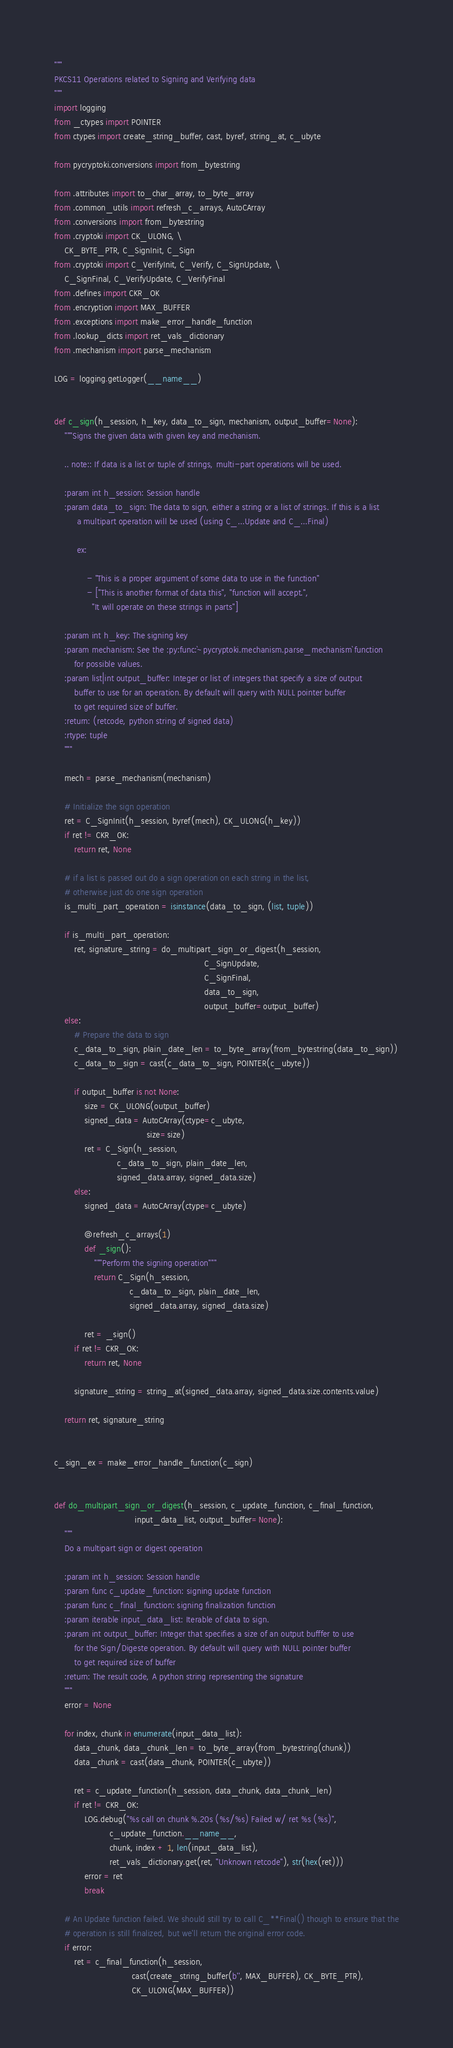Convert code to text. <code><loc_0><loc_0><loc_500><loc_500><_Python_>"""
PKCS11 Operations related to Signing and Verifying data
"""
import logging
from _ctypes import POINTER
from ctypes import create_string_buffer, cast, byref, string_at, c_ubyte

from pycryptoki.conversions import from_bytestring

from .attributes import to_char_array, to_byte_array
from .common_utils import refresh_c_arrays, AutoCArray
from .conversions import from_bytestring
from .cryptoki import CK_ULONG, \
    CK_BYTE_PTR, C_SignInit, C_Sign
from .cryptoki import C_VerifyInit, C_Verify, C_SignUpdate, \
    C_SignFinal, C_VerifyUpdate, C_VerifyFinal
from .defines import CKR_OK
from .encryption import MAX_BUFFER
from .exceptions import make_error_handle_function
from .lookup_dicts import ret_vals_dictionary
from .mechanism import parse_mechanism

LOG = logging.getLogger(__name__)


def c_sign(h_session, h_key, data_to_sign, mechanism, output_buffer=None):
    """Signs the given data with given key and mechanism.

    .. note:: If data is a list or tuple of strings, multi-part operations will be used.

    :param int h_session: Session handle
    :param data_to_sign: The data to sign, either a string or a list of strings. If this is a list
         a multipart operation will be used (using C_...Update and C_...Final)

         ex:

             - "This is a proper argument of some data to use in the function"
             - ["This is another format of data this", "function will accept.",
               "It will operate on these strings in parts"]

    :param int h_key: The signing key
    :param mechanism: See the :py:func:`~pycryptoki.mechanism.parse_mechanism` function
        for possible values.
    :param list|int output_buffer: Integer or list of integers that specify a size of output
        buffer to use for an operation. By default will query with NULL pointer buffer
        to get required size of buffer.
    :return: (retcode, python string of signed data)
    :rtype: tuple
    """

    mech = parse_mechanism(mechanism)

    # Initialize the sign operation
    ret = C_SignInit(h_session, byref(mech), CK_ULONG(h_key))
    if ret != CKR_OK:
        return ret, None

    # if a list is passed out do a sign operation on each string in the list,
    # otherwise just do one sign operation
    is_multi_part_operation = isinstance(data_to_sign, (list, tuple))

    if is_multi_part_operation:
        ret, signature_string = do_multipart_sign_or_digest(h_session,
                                                            C_SignUpdate,
                                                            C_SignFinal,
                                                            data_to_sign,
                                                            output_buffer=output_buffer)
    else:
        # Prepare the data to sign
        c_data_to_sign, plain_date_len = to_byte_array(from_bytestring(data_to_sign))
        c_data_to_sign = cast(c_data_to_sign, POINTER(c_ubyte))

        if output_buffer is not None:
            size = CK_ULONG(output_buffer)
            signed_data = AutoCArray(ctype=c_ubyte,
                                     size=size)
            ret = C_Sign(h_session,
                         c_data_to_sign, plain_date_len,
                         signed_data.array, signed_data.size)
        else:
            signed_data = AutoCArray(ctype=c_ubyte)

            @refresh_c_arrays(1)
            def _sign():
                """Perform the signing operation"""
                return C_Sign(h_session,
                              c_data_to_sign, plain_date_len,
                              signed_data.array, signed_data.size)

            ret = _sign()
        if ret != CKR_OK:
            return ret, None

        signature_string = string_at(signed_data.array, signed_data.size.contents.value)

    return ret, signature_string


c_sign_ex = make_error_handle_function(c_sign)


def do_multipart_sign_or_digest(h_session, c_update_function, c_final_function,
                                input_data_list, output_buffer=None):
    """
    Do a multipart sign or digest operation

    :param int h_session: Session handle
    :param func c_update_function: signing update function
    :param func c_final_function: signing finalization function
    :param iterable input_data_list: Iterable of data to sign.
    :param int output_buffer: Integer that specifies a size of an output bufffer to use
        for the Sign/Digeste operation. By default will query with NULL pointer buffer
        to get required size of buffer
    :return: The result code, A python string representing the signature
    """
    error = None

    for index, chunk in enumerate(input_data_list):
        data_chunk, data_chunk_len = to_byte_array(from_bytestring(chunk))
        data_chunk = cast(data_chunk, POINTER(c_ubyte))

        ret = c_update_function(h_session, data_chunk, data_chunk_len)
        if ret != CKR_OK:
            LOG.debug("%s call on chunk %.20s (%s/%s) Failed w/ ret %s (%s)",
                      c_update_function.__name__,
                      chunk, index + 1, len(input_data_list),
                      ret_vals_dictionary.get(ret, "Unknown retcode"), str(hex(ret)))
            error = ret
            break

    # An Update function failed. We should still try to call C_**Final() though to ensure that the
    # operation is still finalized, but we'll return the original error code. 
    if error:
        ret = c_final_function(h_session,
                               cast(create_string_buffer(b'', MAX_BUFFER), CK_BYTE_PTR),
                               CK_ULONG(MAX_BUFFER))</code> 